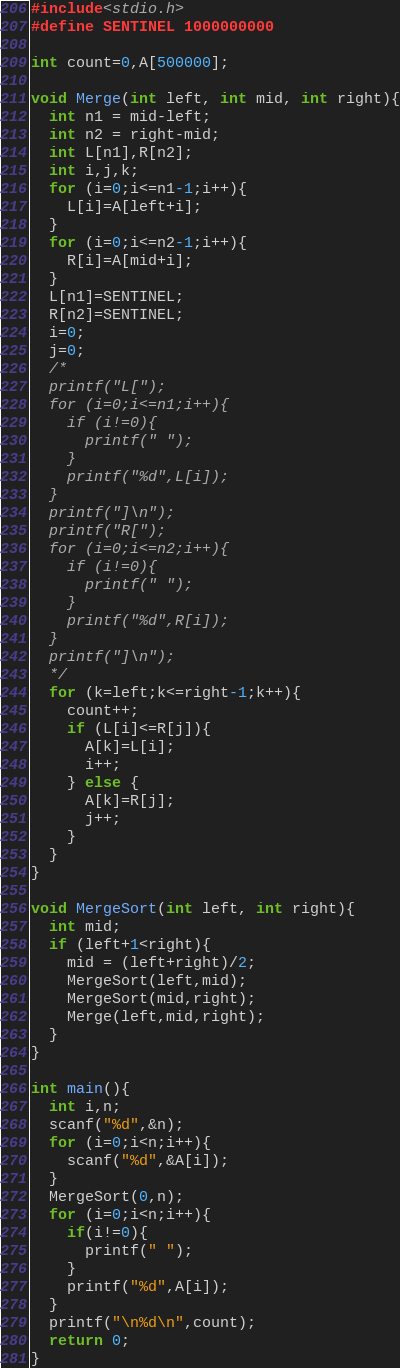<code> <loc_0><loc_0><loc_500><loc_500><_C_>#include<stdio.h>
#define SENTINEL 1000000000
 
int count=0,A[500000];
 
void Merge(int left, int mid, int right){
  int n1 = mid-left;
  int n2 = right-mid;
  int L[n1],R[n2];
  int i,j,k;
  for (i=0;i<=n1-1;i++){
    L[i]=A[left+i];
  }
  for (i=0;i<=n2-1;i++){
    R[i]=A[mid+i];
  }
  L[n1]=SENTINEL;
  R[n2]=SENTINEL;
  i=0;
  j=0;
  /*
  printf("L[");
  for (i=0;i<=n1;i++){
    if (i!=0){
      printf(" ");
    }
    printf("%d",L[i]);
  }
  printf("]\n");
  printf("R[");
  for (i=0;i<=n2;i++){
    if (i!=0){
      printf(" ");
    }
    printf("%d",R[i]);
  }
  printf("]\n");
  */
  for (k=left;k<=right-1;k++){
    count++;
    if (L[i]<=R[j]){
      A[k]=L[i];
      i++;
    } else {
      A[k]=R[j];
      j++;
    }
  }
}
 
void MergeSort(int left, int right){
  int mid;
  if (left+1<right){
    mid = (left+right)/2;
    MergeSort(left,mid);
    MergeSort(mid,right);
    Merge(left,mid,right);
  }
}
 
int main(){
  int i,n;
  scanf("%d",&n);
  for (i=0;i<n;i++){
    scanf("%d",&A[i]);
  }
  MergeSort(0,n);
  for (i=0;i<n;i++){
    if(i!=0){
      printf(" ");
    }
    printf("%d",A[i]);
  }
  printf("\n%d\n",count);
  return 0;
}</code> 